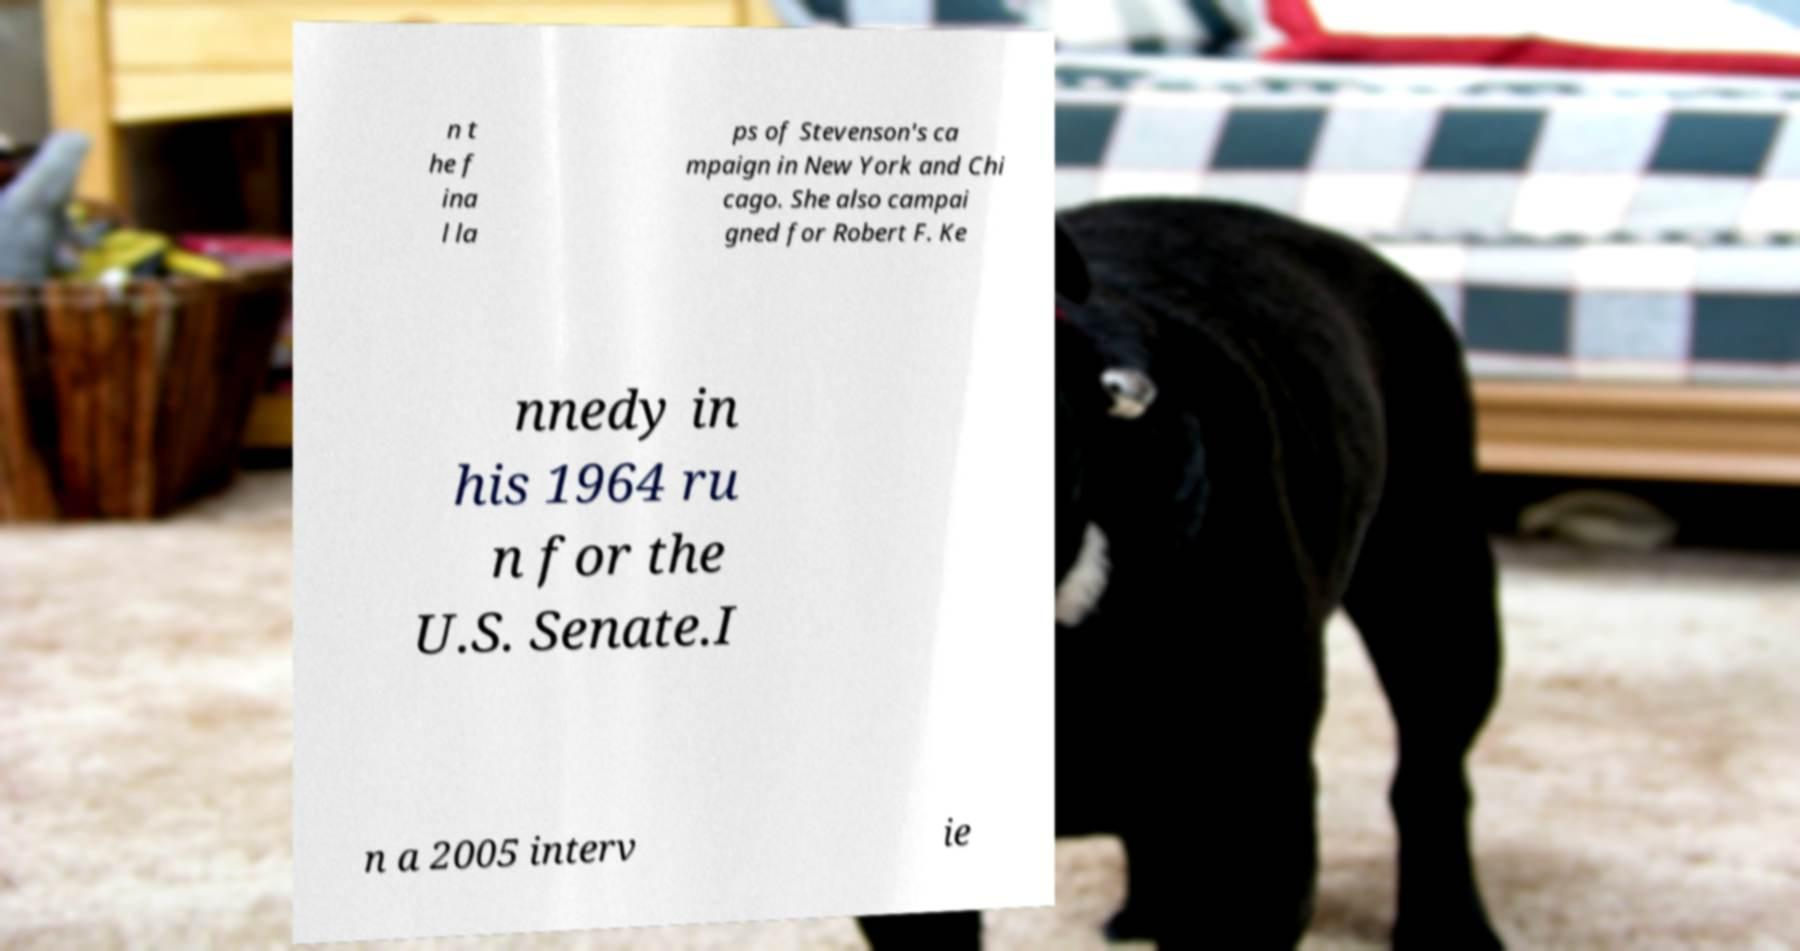What messages or text are displayed in this image? I need them in a readable, typed format. n t he f ina l la ps of Stevenson's ca mpaign in New York and Chi cago. She also campai gned for Robert F. Ke nnedy in his 1964 ru n for the U.S. Senate.I n a 2005 interv ie 